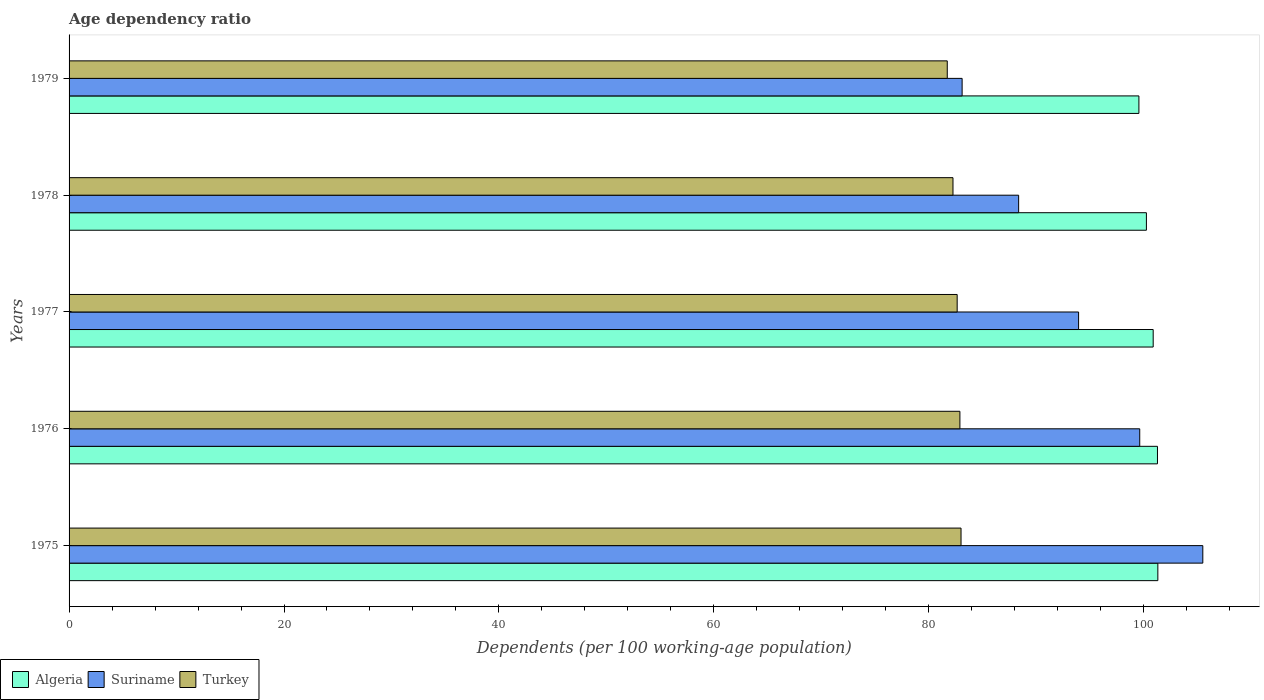Are the number of bars per tick equal to the number of legend labels?
Offer a very short reply. Yes. What is the label of the 3rd group of bars from the top?
Offer a very short reply. 1977. In how many cases, is the number of bars for a given year not equal to the number of legend labels?
Offer a very short reply. 0. What is the age dependency ratio in in Suriname in 1978?
Keep it short and to the point. 88.36. Across all years, what is the maximum age dependency ratio in in Algeria?
Ensure brevity in your answer.  101.31. Across all years, what is the minimum age dependency ratio in in Turkey?
Keep it short and to the point. 81.72. In which year was the age dependency ratio in in Turkey maximum?
Your answer should be very brief. 1975. In which year was the age dependency ratio in in Turkey minimum?
Your response must be concise. 1979. What is the total age dependency ratio in in Algeria in the graph?
Offer a very short reply. 503.28. What is the difference between the age dependency ratio in in Suriname in 1977 and that in 1978?
Your response must be concise. 5.58. What is the difference between the age dependency ratio in in Suriname in 1978 and the age dependency ratio in in Algeria in 1975?
Keep it short and to the point. -12.95. What is the average age dependency ratio in in Turkey per year?
Make the answer very short. 82.5. In the year 1978, what is the difference between the age dependency ratio in in Algeria and age dependency ratio in in Suriname?
Your response must be concise. 11.89. What is the ratio of the age dependency ratio in in Turkey in 1978 to that in 1979?
Keep it short and to the point. 1.01. Is the difference between the age dependency ratio in in Algeria in 1975 and 1978 greater than the difference between the age dependency ratio in in Suriname in 1975 and 1978?
Provide a short and direct response. No. What is the difference between the highest and the second highest age dependency ratio in in Suriname?
Offer a terse response. 5.87. What is the difference between the highest and the lowest age dependency ratio in in Suriname?
Ensure brevity in your answer.  22.4. In how many years, is the age dependency ratio in in Suriname greater than the average age dependency ratio in in Suriname taken over all years?
Provide a succinct answer. 2. Is the sum of the age dependency ratio in in Algeria in 1975 and 1977 greater than the maximum age dependency ratio in in Suriname across all years?
Keep it short and to the point. Yes. What does the 1st bar from the top in 1979 represents?
Offer a terse response. Turkey. What does the 2nd bar from the bottom in 1975 represents?
Give a very brief answer. Suriname. Is it the case that in every year, the sum of the age dependency ratio in in Algeria and age dependency ratio in in Turkey is greater than the age dependency ratio in in Suriname?
Your response must be concise. Yes. How many bars are there?
Keep it short and to the point. 15. Are all the bars in the graph horizontal?
Keep it short and to the point. Yes. Does the graph contain any zero values?
Ensure brevity in your answer.  No. Does the graph contain grids?
Ensure brevity in your answer.  No. Where does the legend appear in the graph?
Ensure brevity in your answer.  Bottom left. What is the title of the graph?
Provide a short and direct response. Age dependency ratio. Does "Micronesia" appear as one of the legend labels in the graph?
Your answer should be compact. No. What is the label or title of the X-axis?
Offer a very short reply. Dependents (per 100 working-age population). What is the Dependents (per 100 working-age population) of Algeria in 1975?
Offer a very short reply. 101.31. What is the Dependents (per 100 working-age population) of Suriname in 1975?
Your answer should be very brief. 105.5. What is the Dependents (per 100 working-age population) of Turkey in 1975?
Provide a short and direct response. 83. What is the Dependents (per 100 working-age population) of Algeria in 1976?
Offer a terse response. 101.28. What is the Dependents (per 100 working-age population) in Suriname in 1976?
Your answer should be compact. 99.63. What is the Dependents (per 100 working-age population) of Turkey in 1976?
Offer a very short reply. 82.9. What is the Dependents (per 100 working-age population) of Algeria in 1977?
Offer a very short reply. 100.88. What is the Dependents (per 100 working-age population) in Suriname in 1977?
Your response must be concise. 93.94. What is the Dependents (per 100 working-age population) in Turkey in 1977?
Give a very brief answer. 82.64. What is the Dependents (per 100 working-age population) of Algeria in 1978?
Provide a succinct answer. 100.25. What is the Dependents (per 100 working-age population) in Suriname in 1978?
Provide a succinct answer. 88.36. What is the Dependents (per 100 working-age population) in Turkey in 1978?
Offer a very short reply. 82.25. What is the Dependents (per 100 working-age population) of Algeria in 1979?
Provide a succinct answer. 99.55. What is the Dependents (per 100 working-age population) in Suriname in 1979?
Make the answer very short. 83.1. What is the Dependents (per 100 working-age population) in Turkey in 1979?
Offer a terse response. 81.72. Across all years, what is the maximum Dependents (per 100 working-age population) in Algeria?
Offer a terse response. 101.31. Across all years, what is the maximum Dependents (per 100 working-age population) in Suriname?
Your response must be concise. 105.5. Across all years, what is the maximum Dependents (per 100 working-age population) of Turkey?
Keep it short and to the point. 83. Across all years, what is the minimum Dependents (per 100 working-age population) in Algeria?
Your answer should be compact. 99.55. Across all years, what is the minimum Dependents (per 100 working-age population) in Suriname?
Ensure brevity in your answer.  83.1. Across all years, what is the minimum Dependents (per 100 working-age population) of Turkey?
Make the answer very short. 81.72. What is the total Dependents (per 100 working-age population) of Algeria in the graph?
Your response must be concise. 503.28. What is the total Dependents (per 100 working-age population) of Suriname in the graph?
Your answer should be very brief. 470.53. What is the total Dependents (per 100 working-age population) of Turkey in the graph?
Ensure brevity in your answer.  412.51. What is the difference between the Dependents (per 100 working-age population) in Algeria in 1975 and that in 1976?
Offer a very short reply. 0.03. What is the difference between the Dependents (per 100 working-age population) in Suriname in 1975 and that in 1976?
Offer a very short reply. 5.87. What is the difference between the Dependents (per 100 working-age population) of Turkey in 1975 and that in 1976?
Make the answer very short. 0.11. What is the difference between the Dependents (per 100 working-age population) in Algeria in 1975 and that in 1977?
Offer a very short reply. 0.43. What is the difference between the Dependents (per 100 working-age population) of Suriname in 1975 and that in 1977?
Offer a terse response. 11.56. What is the difference between the Dependents (per 100 working-age population) of Turkey in 1975 and that in 1977?
Your answer should be compact. 0.36. What is the difference between the Dependents (per 100 working-age population) of Algeria in 1975 and that in 1978?
Offer a terse response. 1.06. What is the difference between the Dependents (per 100 working-age population) of Suriname in 1975 and that in 1978?
Your answer should be compact. 17.14. What is the difference between the Dependents (per 100 working-age population) of Turkey in 1975 and that in 1978?
Offer a very short reply. 0.75. What is the difference between the Dependents (per 100 working-age population) of Algeria in 1975 and that in 1979?
Make the answer very short. 1.76. What is the difference between the Dependents (per 100 working-age population) of Suriname in 1975 and that in 1979?
Your answer should be very brief. 22.4. What is the difference between the Dependents (per 100 working-age population) of Turkey in 1975 and that in 1979?
Make the answer very short. 1.28. What is the difference between the Dependents (per 100 working-age population) in Algeria in 1976 and that in 1977?
Offer a very short reply. 0.4. What is the difference between the Dependents (per 100 working-age population) in Suriname in 1976 and that in 1977?
Keep it short and to the point. 5.69. What is the difference between the Dependents (per 100 working-age population) of Turkey in 1976 and that in 1977?
Your answer should be very brief. 0.25. What is the difference between the Dependents (per 100 working-age population) in Algeria in 1976 and that in 1978?
Your answer should be very brief. 1.03. What is the difference between the Dependents (per 100 working-age population) of Suriname in 1976 and that in 1978?
Provide a succinct answer. 11.27. What is the difference between the Dependents (per 100 working-age population) in Turkey in 1976 and that in 1978?
Offer a very short reply. 0.64. What is the difference between the Dependents (per 100 working-age population) in Algeria in 1976 and that in 1979?
Keep it short and to the point. 1.73. What is the difference between the Dependents (per 100 working-age population) of Suriname in 1976 and that in 1979?
Offer a very short reply. 16.53. What is the difference between the Dependents (per 100 working-age population) in Turkey in 1976 and that in 1979?
Make the answer very short. 1.18. What is the difference between the Dependents (per 100 working-age population) of Algeria in 1977 and that in 1978?
Provide a short and direct response. 0.63. What is the difference between the Dependents (per 100 working-age population) in Suriname in 1977 and that in 1978?
Offer a terse response. 5.58. What is the difference between the Dependents (per 100 working-age population) in Turkey in 1977 and that in 1978?
Provide a succinct answer. 0.39. What is the difference between the Dependents (per 100 working-age population) in Algeria in 1977 and that in 1979?
Give a very brief answer. 1.33. What is the difference between the Dependents (per 100 working-age population) in Suriname in 1977 and that in 1979?
Ensure brevity in your answer.  10.84. What is the difference between the Dependents (per 100 working-age population) of Turkey in 1977 and that in 1979?
Give a very brief answer. 0.92. What is the difference between the Dependents (per 100 working-age population) in Algeria in 1978 and that in 1979?
Provide a short and direct response. 0.7. What is the difference between the Dependents (per 100 working-age population) in Suriname in 1978 and that in 1979?
Offer a very short reply. 5.26. What is the difference between the Dependents (per 100 working-age population) in Turkey in 1978 and that in 1979?
Give a very brief answer. 0.53. What is the difference between the Dependents (per 100 working-age population) of Algeria in 1975 and the Dependents (per 100 working-age population) of Suriname in 1976?
Make the answer very short. 1.68. What is the difference between the Dependents (per 100 working-age population) in Algeria in 1975 and the Dependents (per 100 working-age population) in Turkey in 1976?
Provide a short and direct response. 18.42. What is the difference between the Dependents (per 100 working-age population) in Suriname in 1975 and the Dependents (per 100 working-age population) in Turkey in 1976?
Provide a succinct answer. 22.6. What is the difference between the Dependents (per 100 working-age population) in Algeria in 1975 and the Dependents (per 100 working-age population) in Suriname in 1977?
Give a very brief answer. 7.37. What is the difference between the Dependents (per 100 working-age population) in Algeria in 1975 and the Dependents (per 100 working-age population) in Turkey in 1977?
Provide a short and direct response. 18.67. What is the difference between the Dependents (per 100 working-age population) in Suriname in 1975 and the Dependents (per 100 working-age population) in Turkey in 1977?
Keep it short and to the point. 22.86. What is the difference between the Dependents (per 100 working-age population) in Algeria in 1975 and the Dependents (per 100 working-age population) in Suriname in 1978?
Make the answer very short. 12.95. What is the difference between the Dependents (per 100 working-age population) of Algeria in 1975 and the Dependents (per 100 working-age population) of Turkey in 1978?
Provide a succinct answer. 19.06. What is the difference between the Dependents (per 100 working-age population) of Suriname in 1975 and the Dependents (per 100 working-age population) of Turkey in 1978?
Provide a short and direct response. 23.25. What is the difference between the Dependents (per 100 working-age population) of Algeria in 1975 and the Dependents (per 100 working-age population) of Suriname in 1979?
Offer a terse response. 18.21. What is the difference between the Dependents (per 100 working-age population) of Algeria in 1975 and the Dependents (per 100 working-age population) of Turkey in 1979?
Your answer should be very brief. 19.59. What is the difference between the Dependents (per 100 working-age population) in Suriname in 1975 and the Dependents (per 100 working-age population) in Turkey in 1979?
Provide a short and direct response. 23.78. What is the difference between the Dependents (per 100 working-age population) of Algeria in 1976 and the Dependents (per 100 working-age population) of Suriname in 1977?
Provide a short and direct response. 7.34. What is the difference between the Dependents (per 100 working-age population) in Algeria in 1976 and the Dependents (per 100 working-age population) in Turkey in 1977?
Keep it short and to the point. 18.64. What is the difference between the Dependents (per 100 working-age population) of Suriname in 1976 and the Dependents (per 100 working-age population) of Turkey in 1977?
Ensure brevity in your answer.  16.99. What is the difference between the Dependents (per 100 working-age population) in Algeria in 1976 and the Dependents (per 100 working-age population) in Suriname in 1978?
Offer a terse response. 12.92. What is the difference between the Dependents (per 100 working-age population) of Algeria in 1976 and the Dependents (per 100 working-age population) of Turkey in 1978?
Offer a very short reply. 19.03. What is the difference between the Dependents (per 100 working-age population) in Suriname in 1976 and the Dependents (per 100 working-age population) in Turkey in 1978?
Offer a terse response. 17.38. What is the difference between the Dependents (per 100 working-age population) in Algeria in 1976 and the Dependents (per 100 working-age population) in Suriname in 1979?
Offer a terse response. 18.18. What is the difference between the Dependents (per 100 working-age population) of Algeria in 1976 and the Dependents (per 100 working-age population) of Turkey in 1979?
Offer a very short reply. 19.56. What is the difference between the Dependents (per 100 working-age population) in Suriname in 1976 and the Dependents (per 100 working-age population) in Turkey in 1979?
Your response must be concise. 17.91. What is the difference between the Dependents (per 100 working-age population) of Algeria in 1977 and the Dependents (per 100 working-age population) of Suriname in 1978?
Provide a succinct answer. 12.52. What is the difference between the Dependents (per 100 working-age population) in Algeria in 1977 and the Dependents (per 100 working-age population) in Turkey in 1978?
Your answer should be compact. 18.63. What is the difference between the Dependents (per 100 working-age population) in Suriname in 1977 and the Dependents (per 100 working-age population) in Turkey in 1978?
Provide a succinct answer. 11.69. What is the difference between the Dependents (per 100 working-age population) of Algeria in 1977 and the Dependents (per 100 working-age population) of Suriname in 1979?
Ensure brevity in your answer.  17.78. What is the difference between the Dependents (per 100 working-age population) in Algeria in 1977 and the Dependents (per 100 working-age population) in Turkey in 1979?
Make the answer very short. 19.16. What is the difference between the Dependents (per 100 working-age population) in Suriname in 1977 and the Dependents (per 100 working-age population) in Turkey in 1979?
Your answer should be very brief. 12.22. What is the difference between the Dependents (per 100 working-age population) of Algeria in 1978 and the Dependents (per 100 working-age population) of Suriname in 1979?
Ensure brevity in your answer.  17.15. What is the difference between the Dependents (per 100 working-age population) in Algeria in 1978 and the Dependents (per 100 working-age population) in Turkey in 1979?
Ensure brevity in your answer.  18.53. What is the difference between the Dependents (per 100 working-age population) of Suriname in 1978 and the Dependents (per 100 working-age population) of Turkey in 1979?
Your response must be concise. 6.64. What is the average Dependents (per 100 working-age population) in Algeria per year?
Offer a terse response. 100.66. What is the average Dependents (per 100 working-age population) of Suriname per year?
Ensure brevity in your answer.  94.11. What is the average Dependents (per 100 working-age population) in Turkey per year?
Your response must be concise. 82.5. In the year 1975, what is the difference between the Dependents (per 100 working-age population) in Algeria and Dependents (per 100 working-age population) in Suriname?
Make the answer very short. -4.18. In the year 1975, what is the difference between the Dependents (per 100 working-age population) of Algeria and Dependents (per 100 working-age population) of Turkey?
Keep it short and to the point. 18.31. In the year 1975, what is the difference between the Dependents (per 100 working-age population) in Suriname and Dependents (per 100 working-age population) in Turkey?
Offer a terse response. 22.5. In the year 1976, what is the difference between the Dependents (per 100 working-age population) of Algeria and Dependents (per 100 working-age population) of Suriname?
Your answer should be compact. 1.65. In the year 1976, what is the difference between the Dependents (per 100 working-age population) of Algeria and Dependents (per 100 working-age population) of Turkey?
Your answer should be compact. 18.38. In the year 1976, what is the difference between the Dependents (per 100 working-age population) in Suriname and Dependents (per 100 working-age population) in Turkey?
Give a very brief answer. 16.73. In the year 1977, what is the difference between the Dependents (per 100 working-age population) of Algeria and Dependents (per 100 working-age population) of Suriname?
Provide a succinct answer. 6.94. In the year 1977, what is the difference between the Dependents (per 100 working-age population) of Algeria and Dependents (per 100 working-age population) of Turkey?
Give a very brief answer. 18.24. In the year 1977, what is the difference between the Dependents (per 100 working-age population) of Suriname and Dependents (per 100 working-age population) of Turkey?
Your answer should be very brief. 11.3. In the year 1978, what is the difference between the Dependents (per 100 working-age population) in Algeria and Dependents (per 100 working-age population) in Suriname?
Keep it short and to the point. 11.89. In the year 1978, what is the difference between the Dependents (per 100 working-age population) of Algeria and Dependents (per 100 working-age population) of Turkey?
Your answer should be very brief. 18. In the year 1978, what is the difference between the Dependents (per 100 working-age population) in Suriname and Dependents (per 100 working-age population) in Turkey?
Keep it short and to the point. 6.11. In the year 1979, what is the difference between the Dependents (per 100 working-age population) in Algeria and Dependents (per 100 working-age population) in Suriname?
Your response must be concise. 16.45. In the year 1979, what is the difference between the Dependents (per 100 working-age population) in Algeria and Dependents (per 100 working-age population) in Turkey?
Provide a short and direct response. 17.83. In the year 1979, what is the difference between the Dependents (per 100 working-age population) in Suriname and Dependents (per 100 working-age population) in Turkey?
Make the answer very short. 1.38. What is the ratio of the Dependents (per 100 working-age population) of Algeria in 1975 to that in 1976?
Give a very brief answer. 1. What is the ratio of the Dependents (per 100 working-age population) in Suriname in 1975 to that in 1976?
Keep it short and to the point. 1.06. What is the ratio of the Dependents (per 100 working-age population) in Algeria in 1975 to that in 1977?
Ensure brevity in your answer.  1. What is the ratio of the Dependents (per 100 working-age population) in Suriname in 1975 to that in 1977?
Offer a very short reply. 1.12. What is the ratio of the Dependents (per 100 working-age population) of Turkey in 1975 to that in 1977?
Your answer should be compact. 1. What is the ratio of the Dependents (per 100 working-age population) in Algeria in 1975 to that in 1978?
Provide a succinct answer. 1.01. What is the ratio of the Dependents (per 100 working-age population) in Suriname in 1975 to that in 1978?
Make the answer very short. 1.19. What is the ratio of the Dependents (per 100 working-age population) in Turkey in 1975 to that in 1978?
Offer a terse response. 1.01. What is the ratio of the Dependents (per 100 working-age population) of Algeria in 1975 to that in 1979?
Offer a terse response. 1.02. What is the ratio of the Dependents (per 100 working-age population) in Suriname in 1975 to that in 1979?
Keep it short and to the point. 1.27. What is the ratio of the Dependents (per 100 working-age population) in Turkey in 1975 to that in 1979?
Your answer should be compact. 1.02. What is the ratio of the Dependents (per 100 working-age population) of Algeria in 1976 to that in 1977?
Make the answer very short. 1. What is the ratio of the Dependents (per 100 working-age population) of Suriname in 1976 to that in 1977?
Make the answer very short. 1.06. What is the ratio of the Dependents (per 100 working-age population) in Turkey in 1976 to that in 1977?
Provide a short and direct response. 1. What is the ratio of the Dependents (per 100 working-age population) of Algeria in 1976 to that in 1978?
Give a very brief answer. 1.01. What is the ratio of the Dependents (per 100 working-age population) of Suriname in 1976 to that in 1978?
Ensure brevity in your answer.  1.13. What is the ratio of the Dependents (per 100 working-age population) of Algeria in 1976 to that in 1979?
Your answer should be compact. 1.02. What is the ratio of the Dependents (per 100 working-age population) of Suriname in 1976 to that in 1979?
Make the answer very short. 1.2. What is the ratio of the Dependents (per 100 working-age population) of Turkey in 1976 to that in 1979?
Your answer should be compact. 1.01. What is the ratio of the Dependents (per 100 working-age population) of Algeria in 1977 to that in 1978?
Your answer should be very brief. 1.01. What is the ratio of the Dependents (per 100 working-age population) of Suriname in 1977 to that in 1978?
Keep it short and to the point. 1.06. What is the ratio of the Dependents (per 100 working-age population) in Algeria in 1977 to that in 1979?
Provide a succinct answer. 1.01. What is the ratio of the Dependents (per 100 working-age population) in Suriname in 1977 to that in 1979?
Your answer should be very brief. 1.13. What is the ratio of the Dependents (per 100 working-age population) of Turkey in 1977 to that in 1979?
Give a very brief answer. 1.01. What is the ratio of the Dependents (per 100 working-age population) in Algeria in 1978 to that in 1979?
Your answer should be very brief. 1.01. What is the ratio of the Dependents (per 100 working-age population) of Suriname in 1978 to that in 1979?
Make the answer very short. 1.06. What is the difference between the highest and the second highest Dependents (per 100 working-age population) of Algeria?
Make the answer very short. 0.03. What is the difference between the highest and the second highest Dependents (per 100 working-age population) in Suriname?
Offer a very short reply. 5.87. What is the difference between the highest and the second highest Dependents (per 100 working-age population) in Turkey?
Provide a succinct answer. 0.11. What is the difference between the highest and the lowest Dependents (per 100 working-age population) in Algeria?
Your answer should be very brief. 1.76. What is the difference between the highest and the lowest Dependents (per 100 working-age population) of Suriname?
Your answer should be compact. 22.4. What is the difference between the highest and the lowest Dependents (per 100 working-age population) in Turkey?
Provide a succinct answer. 1.28. 